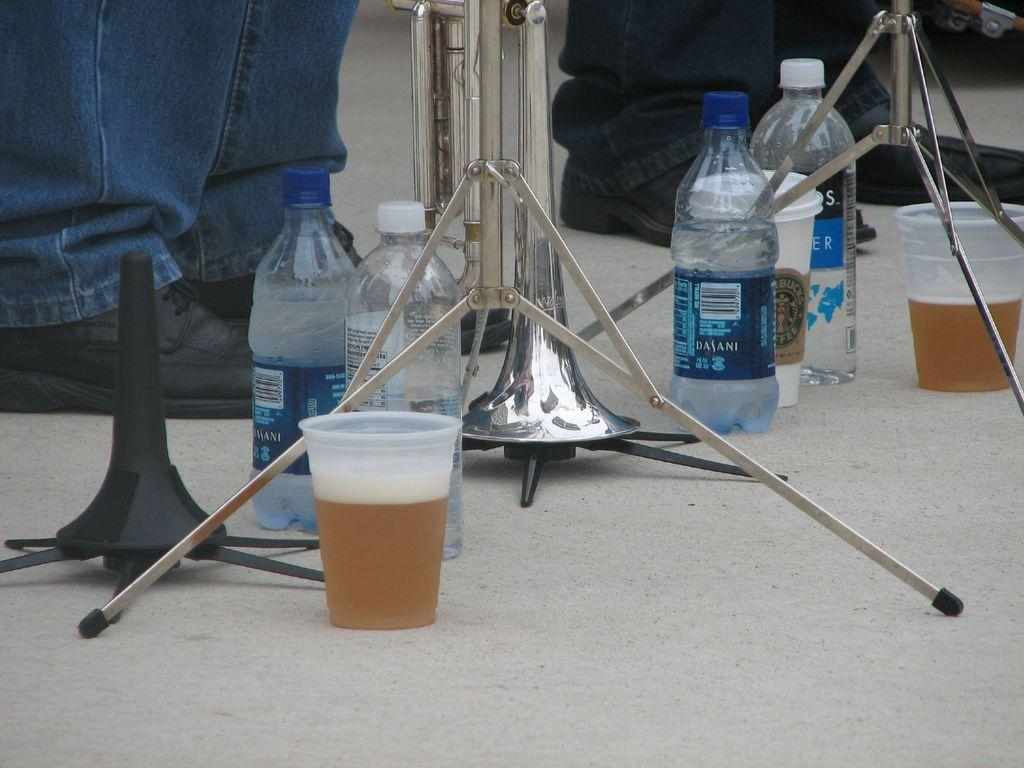What body parts are visible in the image? There are two persons' legs in the image. What type of containers can be seen in the image? There are bottles and glasses with a drink in them in the image. What is the purpose of the stand in the image? The stand is likely used to hold or display items, but its specific purpose is not clear from the facts provided. What musical instrument is on the floor in the image? There is a saxophone on the floor in the image. What type of paste is being used to hold the paper on the wall in the image? There is no mention of paste or paper on the wall in the image. How many potatoes are visible in the image? There are no potatoes present in the image. 